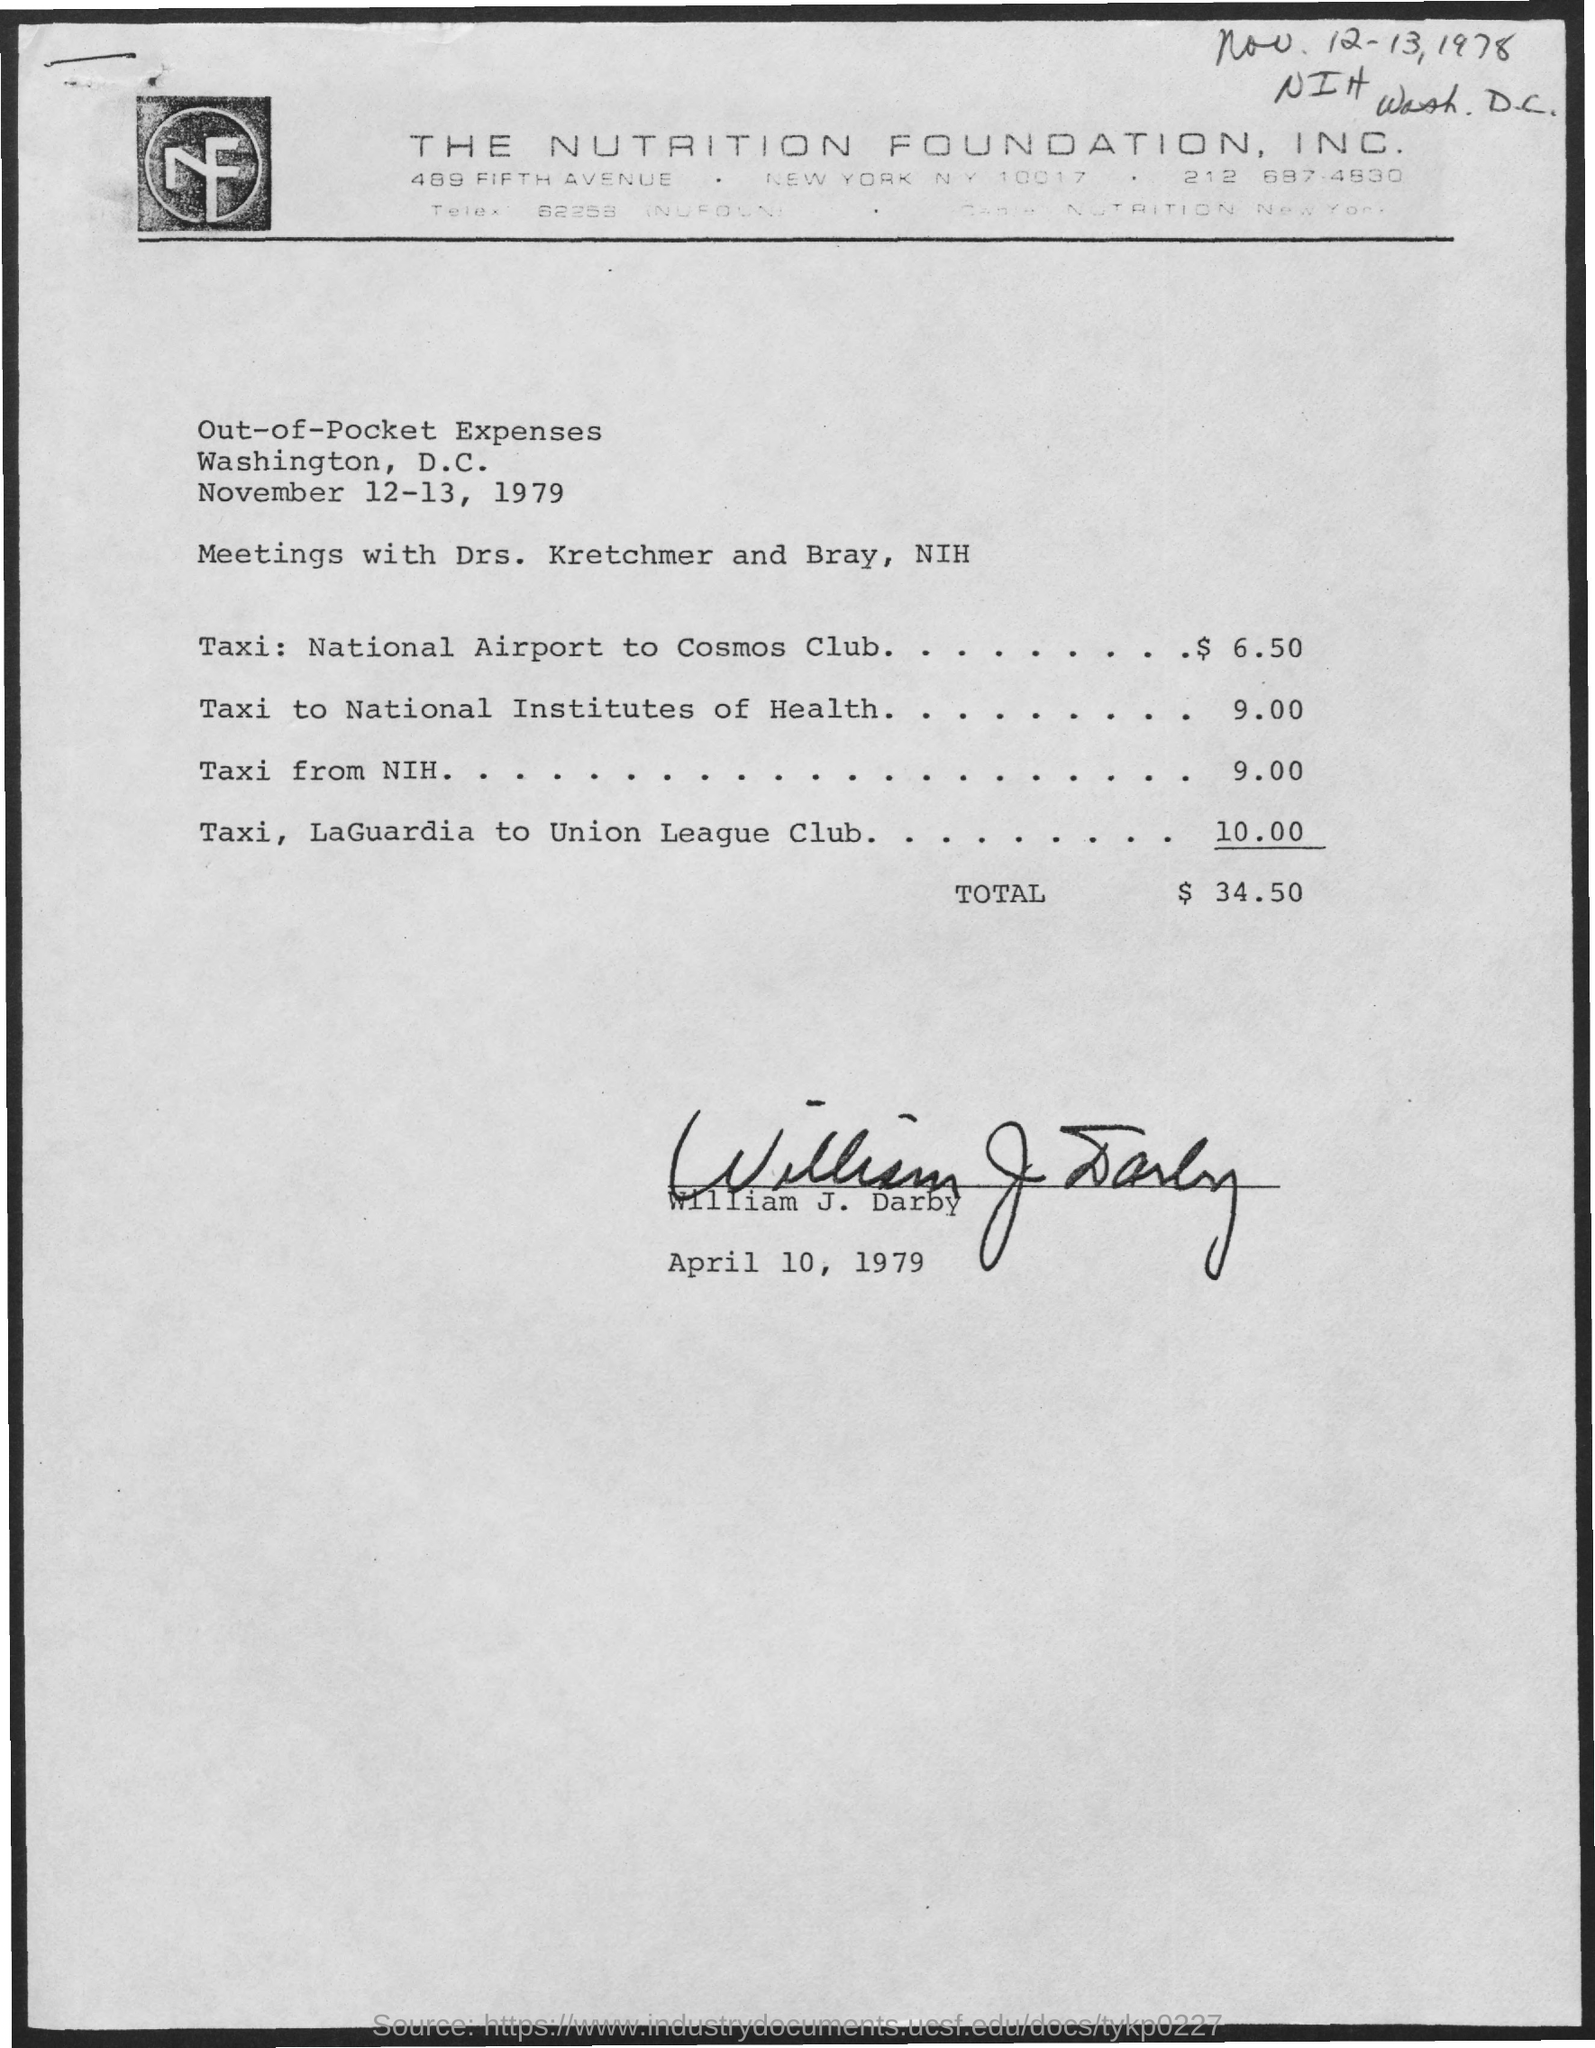Point out several critical features in this image. This expense sheet is provided by William J. Darby. A taxi ride from LaGuardia Airport to the Union League Club is estimated to cost $10.00. The Nutrition Foundation is located in New York City. The cost of a taxi from NIH is approximately $9.00. The total amount is $34.50. 